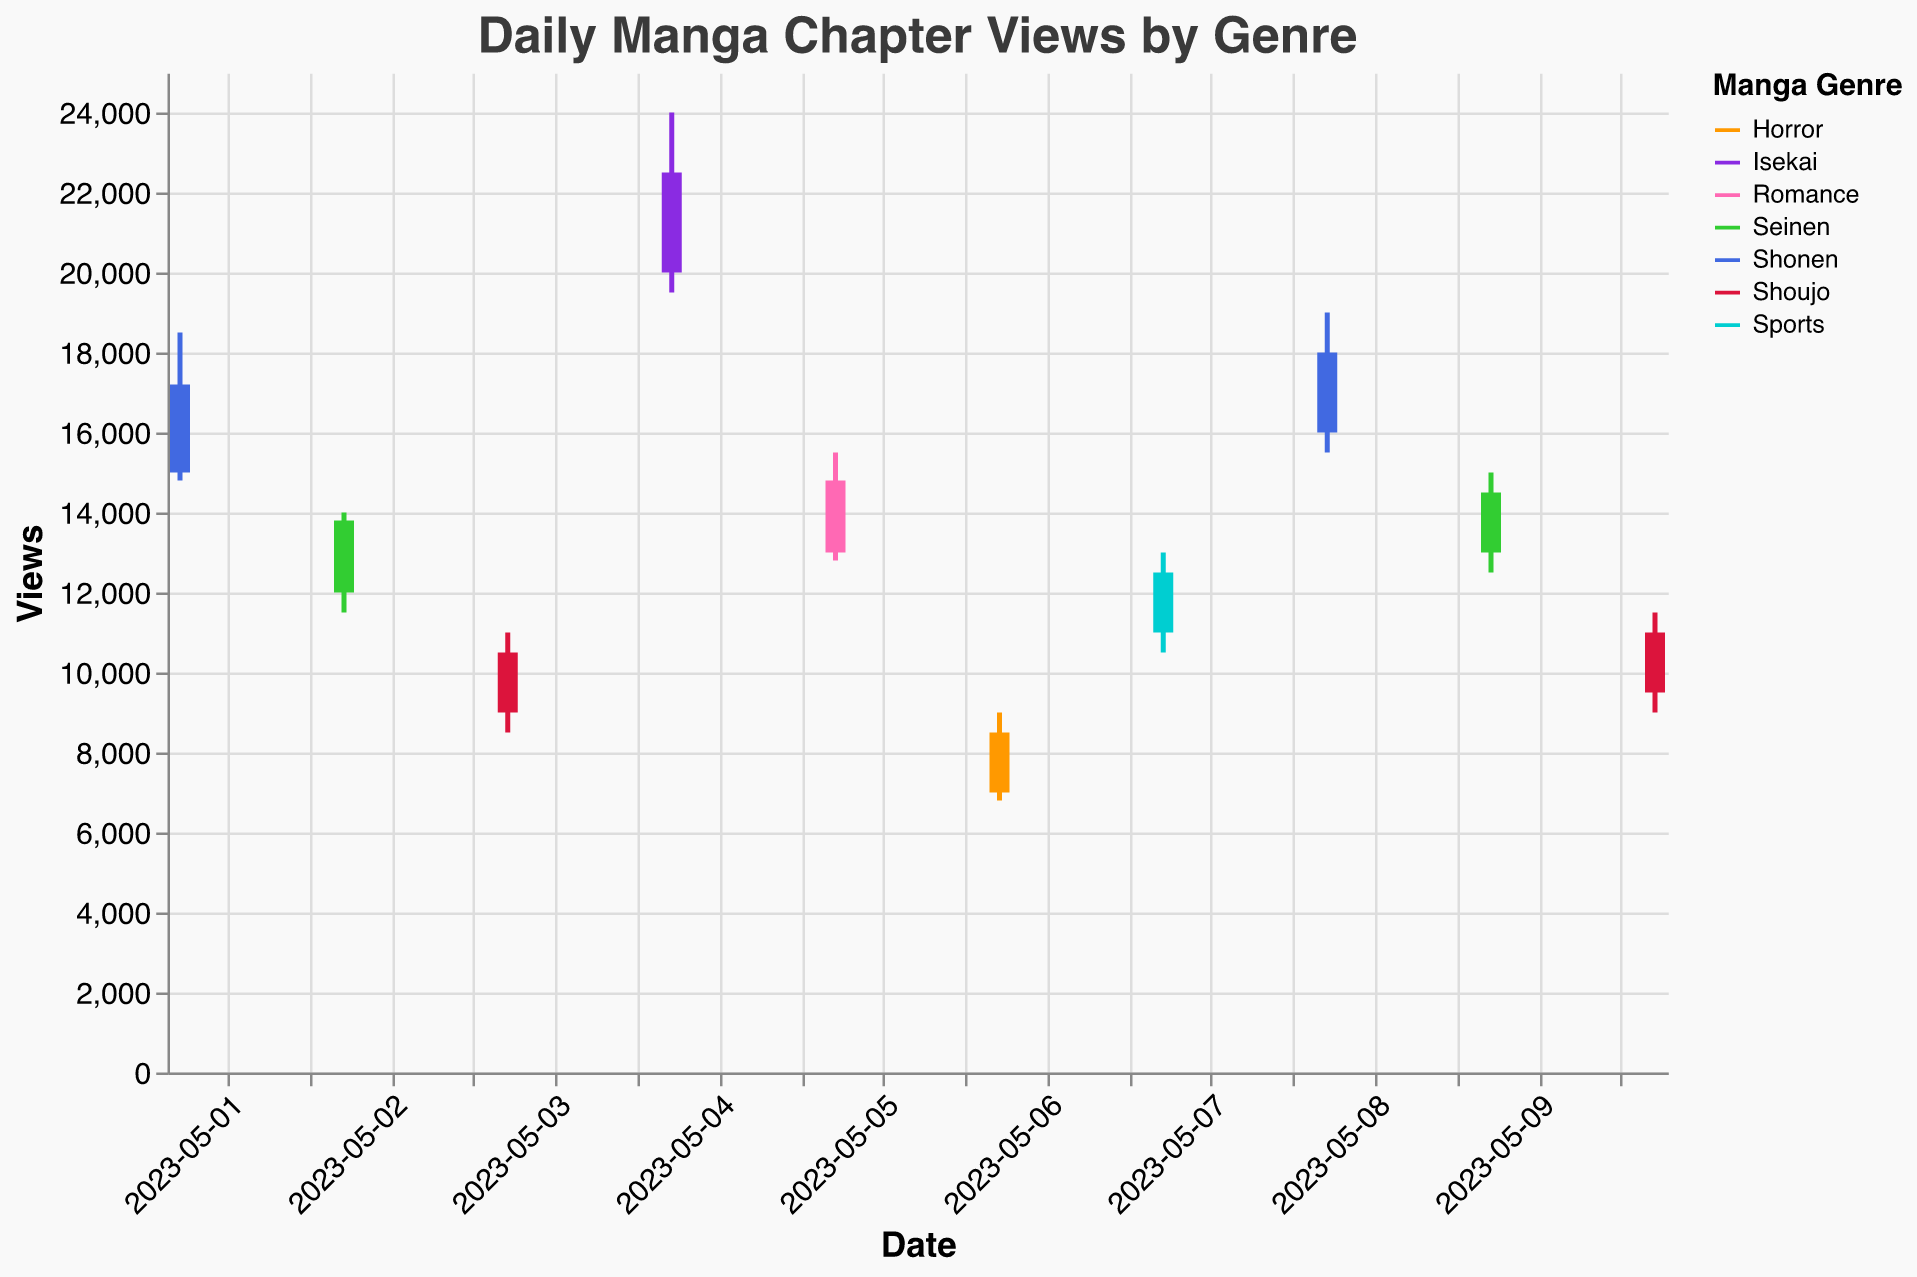What is the maximum number of views recorded for the Shonen genre on May 1st, 2023? The maximum number of views is represented by the "High" value in the OHLC chart for the Shonen genre on May 1st. Looking at the figure, the 'High' value for Shonen on this date is 18,500.
Answer: 18,500 What is the range of views for the Isekai genre on May 4th, 2023? The range of views is the difference between the 'High' and 'Low' values for the given date and genre. For Isekai on May 4th, the 'High' value is 24,000 and the 'Low' value is 19,500. So, the range is 24,000 - 19,500.
Answer: 4,500 Which genre has the lowest closing value across all dates? To find the lowest closing value, we need to check the 'Close' values for each genre and date. The lowest 'Close' value is 8,500 for the Horror genre on May 6th.
Answer: Horror On May 2nd, what is the difference between the closing value and opening value for the Seinen genre? For Seinen on May 2nd, the 'Close' value is 13,800 and the 'Open' value is 12,000. The difference is 13,800 - 12,000.
Answer: 1,800 How many days does the Shoujo genre appear in the given data set? To determine the number of days Shoujo appears, count the rows with the Shoujo genre. It appears on May 3rd and May 10th, making it 2 days.
Answer: 2 Which genre showed the highest upward movement from opening to closing on any single day? The highest upward movement is the maximum positive difference between 'Close' and 'Open' values across all genres and dates. Isekai on May 4th has an open of 20,000 and closes at 22,500, giving a rise of 22,500 - 20,000.
Answer: Isekai What is the median of the closing values recorded for the Seinen genre? First, list the closing values for Seinen (13,800 and 14,500). Since there are only two values, the median is the average of these values. The median is (13,800 + 14,500) / 2.
Answer: 14,150 Which genre had the highest volatility on May 7th, 2023? Volatility can be gauged by the range from 'High' to 'Low.' For May 7th, only the Sports genre is listed with a 'High' of 13,000 and a 'Low' of 10,500, giving volatility of 13,000 - 10,500.
Answer: Sports 